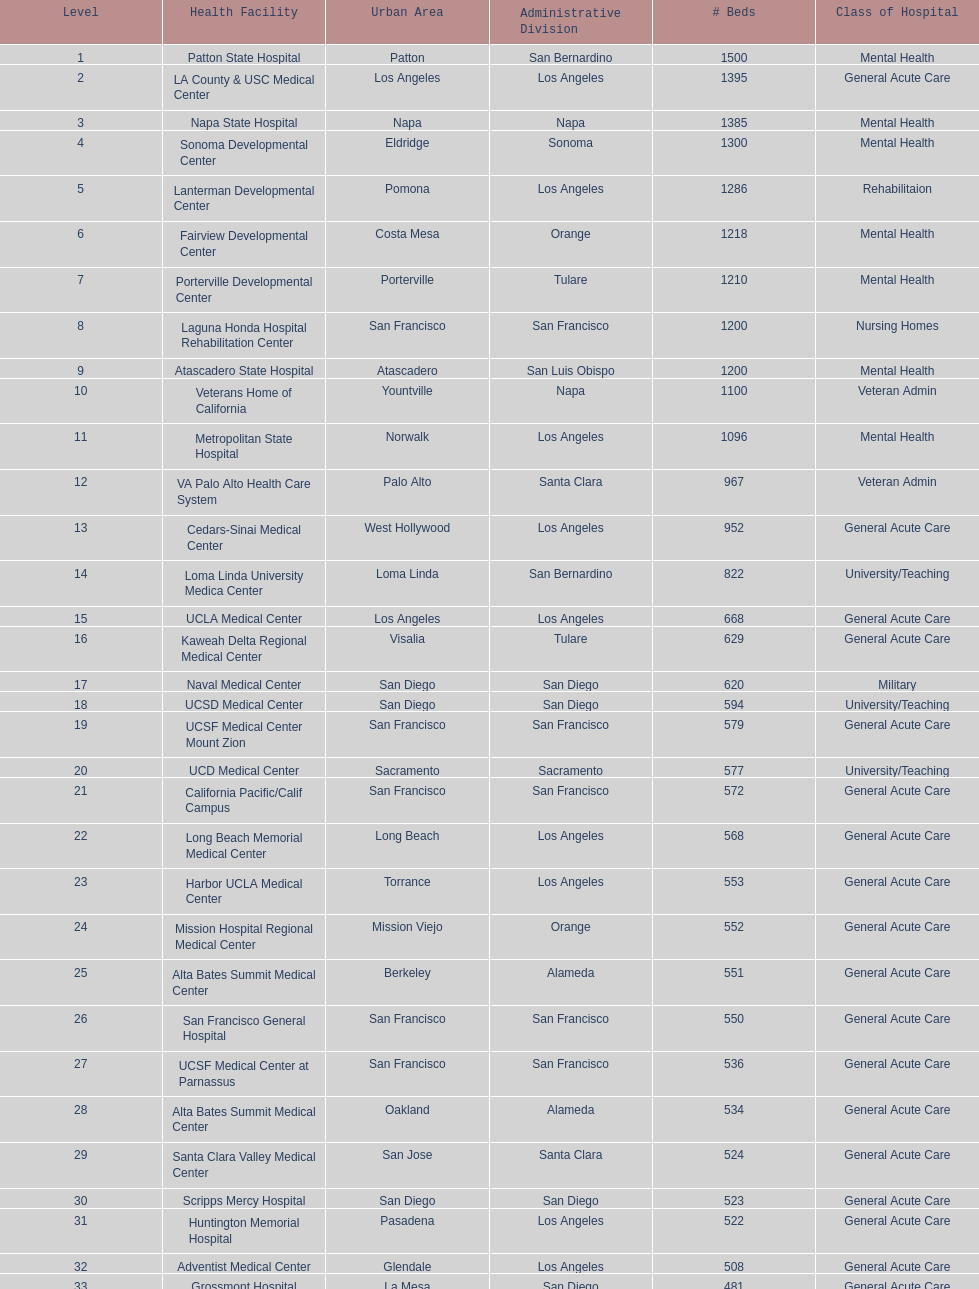What two hospitals holding consecutive rankings of 8 and 9 respectively, both provide 1200 hospital beds? Laguna Honda Hospital Rehabilitation Center, Atascadero State Hospital. 